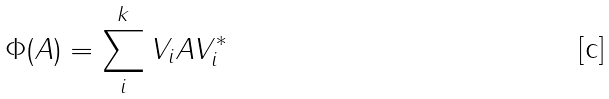Convert formula to latex. <formula><loc_0><loc_0><loc_500><loc_500>\Phi ( A ) = \sum _ { i } ^ { k } V _ { i } A V _ { i } ^ { * }</formula> 